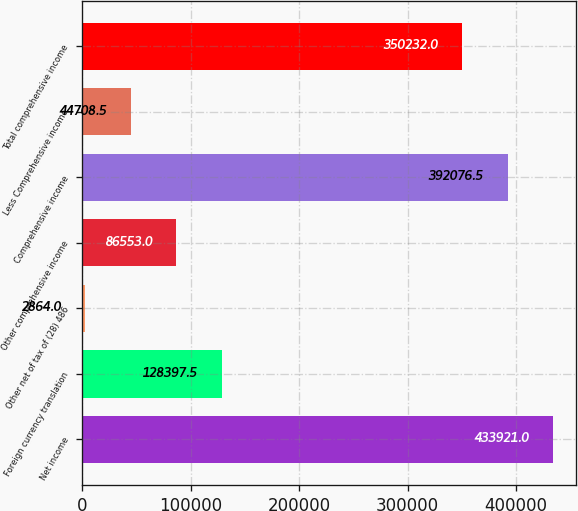Convert chart. <chart><loc_0><loc_0><loc_500><loc_500><bar_chart><fcel>Net income<fcel>Foreign currency translation<fcel>Other net of tax of (28) 486<fcel>Other comprehensive income<fcel>Comprehensive income<fcel>Less Comprehensive income<fcel>Total comprehensive income<nl><fcel>433921<fcel>128398<fcel>2864<fcel>86553<fcel>392076<fcel>44708.5<fcel>350232<nl></chart> 